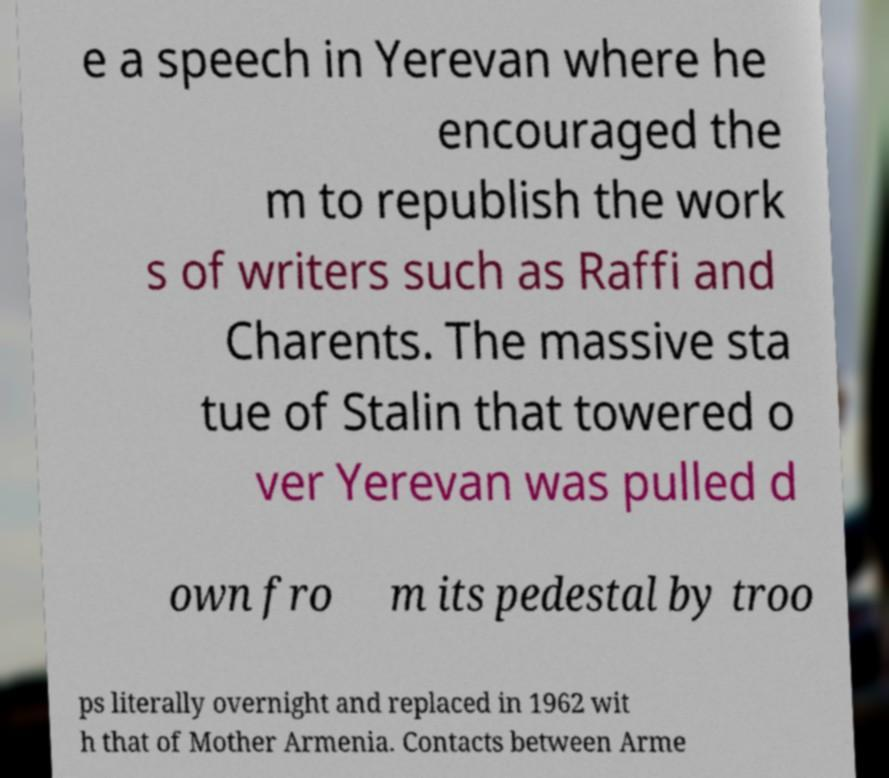Could you extract and type out the text from this image? e a speech in Yerevan where he encouraged the m to republish the work s of writers such as Raffi and Charents. The massive sta tue of Stalin that towered o ver Yerevan was pulled d own fro m its pedestal by troo ps literally overnight and replaced in 1962 wit h that of Mother Armenia. Contacts between Arme 